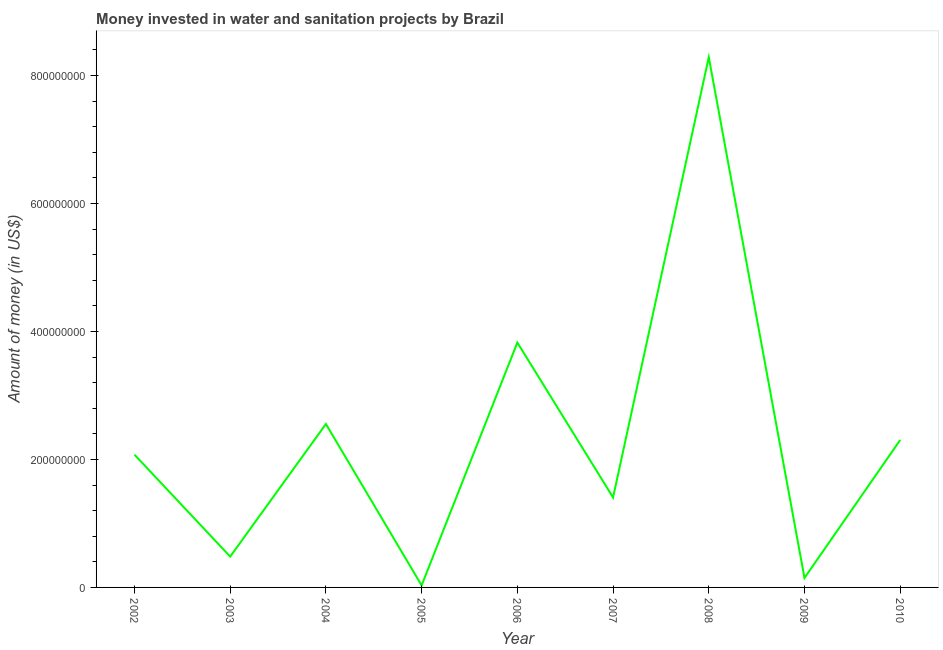What is the investment in 2002?
Offer a very short reply. 2.07e+08. Across all years, what is the maximum investment?
Ensure brevity in your answer.  8.28e+08. Across all years, what is the minimum investment?
Offer a terse response. 3.16e+06. In which year was the investment maximum?
Offer a very short reply. 2008. What is the sum of the investment?
Your response must be concise. 2.11e+09. What is the difference between the investment in 2003 and 2004?
Make the answer very short. -2.07e+08. What is the average investment per year?
Ensure brevity in your answer.  2.35e+08. What is the median investment?
Keep it short and to the point. 2.07e+08. In how many years, is the investment greater than 280000000 US$?
Ensure brevity in your answer.  2. What is the ratio of the investment in 2009 to that in 2010?
Provide a short and direct response. 0.06. Is the difference between the investment in 2005 and 2006 greater than the difference between any two years?
Ensure brevity in your answer.  No. What is the difference between the highest and the second highest investment?
Ensure brevity in your answer.  4.46e+08. Is the sum of the investment in 2002 and 2007 greater than the maximum investment across all years?
Your answer should be compact. No. What is the difference between the highest and the lowest investment?
Offer a terse response. 8.25e+08. How many lines are there?
Make the answer very short. 1. How many years are there in the graph?
Offer a very short reply. 9. What is the difference between two consecutive major ticks on the Y-axis?
Give a very brief answer. 2.00e+08. Are the values on the major ticks of Y-axis written in scientific E-notation?
Provide a succinct answer. No. Does the graph contain any zero values?
Ensure brevity in your answer.  No. Does the graph contain grids?
Keep it short and to the point. No. What is the title of the graph?
Provide a succinct answer. Money invested in water and sanitation projects by Brazil. What is the label or title of the X-axis?
Offer a very short reply. Year. What is the label or title of the Y-axis?
Provide a short and direct response. Amount of money (in US$). What is the Amount of money (in US$) in 2002?
Offer a terse response. 2.07e+08. What is the Amount of money (in US$) of 2003?
Offer a terse response. 4.82e+07. What is the Amount of money (in US$) in 2004?
Give a very brief answer. 2.55e+08. What is the Amount of money (in US$) of 2005?
Keep it short and to the point. 3.16e+06. What is the Amount of money (in US$) of 2006?
Ensure brevity in your answer.  3.83e+08. What is the Amount of money (in US$) of 2007?
Your answer should be compact. 1.41e+08. What is the Amount of money (in US$) of 2008?
Your answer should be compact. 8.28e+08. What is the Amount of money (in US$) of 2009?
Offer a very short reply. 1.48e+07. What is the Amount of money (in US$) of 2010?
Your answer should be compact. 2.30e+08. What is the difference between the Amount of money (in US$) in 2002 and 2003?
Keep it short and to the point. 1.59e+08. What is the difference between the Amount of money (in US$) in 2002 and 2004?
Your answer should be very brief. -4.79e+07. What is the difference between the Amount of money (in US$) in 2002 and 2005?
Provide a short and direct response. 2.04e+08. What is the difference between the Amount of money (in US$) in 2002 and 2006?
Keep it short and to the point. -1.75e+08. What is the difference between the Amount of money (in US$) in 2002 and 2007?
Provide a succinct answer. 6.69e+07. What is the difference between the Amount of money (in US$) in 2002 and 2008?
Your answer should be compact. -6.21e+08. What is the difference between the Amount of money (in US$) in 2002 and 2009?
Offer a terse response. 1.93e+08. What is the difference between the Amount of money (in US$) in 2002 and 2010?
Your answer should be compact. -2.29e+07. What is the difference between the Amount of money (in US$) in 2003 and 2004?
Give a very brief answer. -2.07e+08. What is the difference between the Amount of money (in US$) in 2003 and 2005?
Your answer should be very brief. 4.50e+07. What is the difference between the Amount of money (in US$) in 2003 and 2006?
Ensure brevity in your answer.  -3.34e+08. What is the difference between the Amount of money (in US$) in 2003 and 2007?
Offer a terse response. -9.24e+07. What is the difference between the Amount of money (in US$) in 2003 and 2008?
Your response must be concise. -7.80e+08. What is the difference between the Amount of money (in US$) in 2003 and 2009?
Offer a very short reply. 3.34e+07. What is the difference between the Amount of money (in US$) in 2003 and 2010?
Provide a short and direct response. -1.82e+08. What is the difference between the Amount of money (in US$) in 2004 and 2005?
Provide a succinct answer. 2.52e+08. What is the difference between the Amount of money (in US$) in 2004 and 2006?
Offer a very short reply. -1.27e+08. What is the difference between the Amount of money (in US$) in 2004 and 2007?
Offer a terse response. 1.15e+08. What is the difference between the Amount of money (in US$) in 2004 and 2008?
Your answer should be compact. -5.73e+08. What is the difference between the Amount of money (in US$) in 2004 and 2009?
Provide a short and direct response. 2.41e+08. What is the difference between the Amount of money (in US$) in 2004 and 2010?
Make the answer very short. 2.49e+07. What is the difference between the Amount of money (in US$) in 2005 and 2006?
Give a very brief answer. -3.79e+08. What is the difference between the Amount of money (in US$) in 2005 and 2007?
Ensure brevity in your answer.  -1.37e+08. What is the difference between the Amount of money (in US$) in 2005 and 2008?
Provide a short and direct response. -8.25e+08. What is the difference between the Amount of money (in US$) in 2005 and 2009?
Offer a terse response. -1.16e+07. What is the difference between the Amount of money (in US$) in 2005 and 2010?
Make the answer very short. -2.27e+08. What is the difference between the Amount of money (in US$) in 2006 and 2007?
Ensure brevity in your answer.  2.42e+08. What is the difference between the Amount of money (in US$) in 2006 and 2008?
Give a very brief answer. -4.46e+08. What is the difference between the Amount of money (in US$) in 2006 and 2009?
Ensure brevity in your answer.  3.68e+08. What is the difference between the Amount of money (in US$) in 2006 and 2010?
Your answer should be compact. 1.52e+08. What is the difference between the Amount of money (in US$) in 2007 and 2008?
Give a very brief answer. -6.88e+08. What is the difference between the Amount of money (in US$) in 2007 and 2009?
Offer a terse response. 1.26e+08. What is the difference between the Amount of money (in US$) in 2007 and 2010?
Your answer should be compact. -8.98e+07. What is the difference between the Amount of money (in US$) in 2008 and 2009?
Provide a succinct answer. 8.14e+08. What is the difference between the Amount of money (in US$) in 2008 and 2010?
Your answer should be very brief. 5.98e+08. What is the difference between the Amount of money (in US$) in 2009 and 2010?
Your answer should be very brief. -2.16e+08. What is the ratio of the Amount of money (in US$) in 2002 to that in 2003?
Ensure brevity in your answer.  4.3. What is the ratio of the Amount of money (in US$) in 2002 to that in 2004?
Ensure brevity in your answer.  0.81. What is the ratio of the Amount of money (in US$) in 2002 to that in 2005?
Keep it short and to the point. 65.57. What is the ratio of the Amount of money (in US$) in 2002 to that in 2006?
Offer a terse response. 0.54. What is the ratio of the Amount of money (in US$) in 2002 to that in 2007?
Your answer should be compact. 1.48. What is the ratio of the Amount of money (in US$) in 2002 to that in 2009?
Your answer should be very brief. 14.02. What is the ratio of the Amount of money (in US$) in 2003 to that in 2004?
Ensure brevity in your answer.  0.19. What is the ratio of the Amount of money (in US$) in 2003 to that in 2005?
Your response must be concise. 15.23. What is the ratio of the Amount of money (in US$) in 2003 to that in 2006?
Keep it short and to the point. 0.13. What is the ratio of the Amount of money (in US$) in 2003 to that in 2007?
Offer a terse response. 0.34. What is the ratio of the Amount of money (in US$) in 2003 to that in 2008?
Ensure brevity in your answer.  0.06. What is the ratio of the Amount of money (in US$) in 2003 to that in 2009?
Offer a terse response. 3.26. What is the ratio of the Amount of money (in US$) in 2003 to that in 2010?
Offer a terse response. 0.21. What is the ratio of the Amount of money (in US$) in 2004 to that in 2005?
Your answer should be very brief. 80.7. What is the ratio of the Amount of money (in US$) in 2004 to that in 2006?
Your answer should be very brief. 0.67. What is the ratio of the Amount of money (in US$) in 2004 to that in 2007?
Your response must be concise. 1.82. What is the ratio of the Amount of money (in US$) in 2004 to that in 2008?
Offer a very short reply. 0.31. What is the ratio of the Amount of money (in US$) in 2004 to that in 2009?
Your answer should be compact. 17.25. What is the ratio of the Amount of money (in US$) in 2004 to that in 2010?
Offer a very short reply. 1.11. What is the ratio of the Amount of money (in US$) in 2005 to that in 2006?
Offer a terse response. 0.01. What is the ratio of the Amount of money (in US$) in 2005 to that in 2007?
Ensure brevity in your answer.  0.02. What is the ratio of the Amount of money (in US$) in 2005 to that in 2008?
Provide a succinct answer. 0. What is the ratio of the Amount of money (in US$) in 2005 to that in 2009?
Keep it short and to the point. 0.21. What is the ratio of the Amount of money (in US$) in 2005 to that in 2010?
Provide a short and direct response. 0.01. What is the ratio of the Amount of money (in US$) in 2006 to that in 2007?
Make the answer very short. 2.72. What is the ratio of the Amount of money (in US$) in 2006 to that in 2008?
Give a very brief answer. 0.46. What is the ratio of the Amount of money (in US$) in 2006 to that in 2009?
Your answer should be compact. 25.85. What is the ratio of the Amount of money (in US$) in 2006 to that in 2010?
Provide a succinct answer. 1.66. What is the ratio of the Amount of money (in US$) in 2007 to that in 2008?
Give a very brief answer. 0.17. What is the ratio of the Amount of money (in US$) in 2007 to that in 2009?
Your answer should be compact. 9.5. What is the ratio of the Amount of money (in US$) in 2007 to that in 2010?
Make the answer very short. 0.61. What is the ratio of the Amount of money (in US$) in 2008 to that in 2009?
Your answer should be compact. 55.97. What is the ratio of the Amount of money (in US$) in 2008 to that in 2010?
Make the answer very short. 3.6. What is the ratio of the Amount of money (in US$) in 2009 to that in 2010?
Provide a short and direct response. 0.06. 